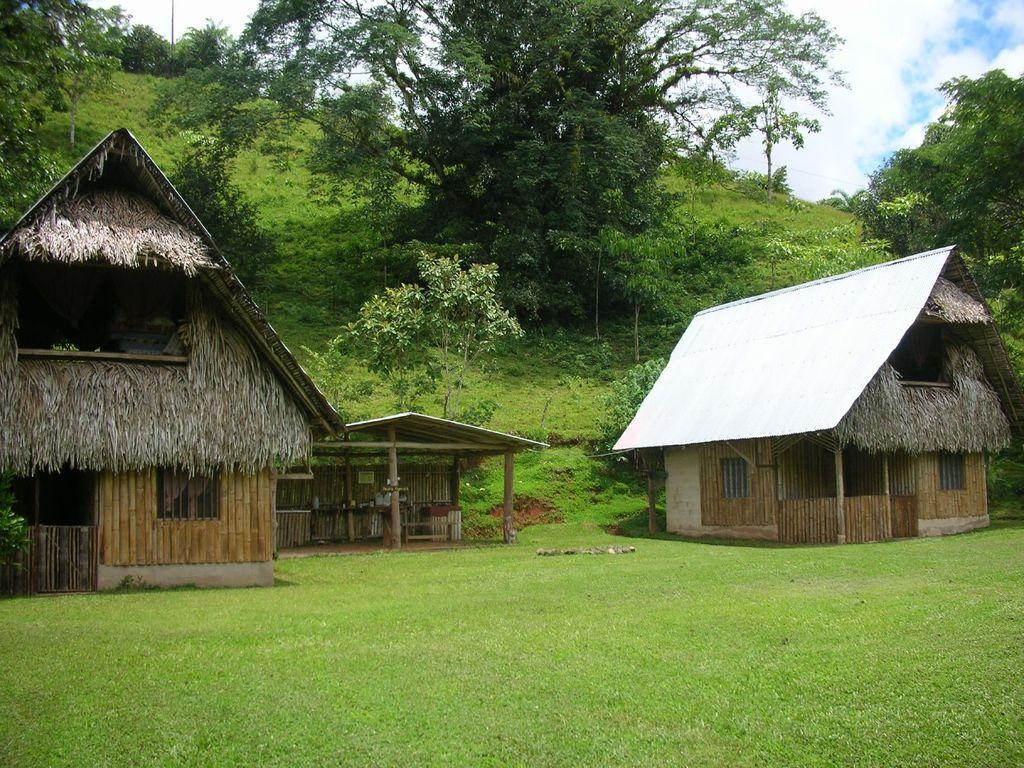How many wooden houses are present in the image? There are three wooden houses in the image. What type of vegetation can be seen in the background of the image? There are trees in the background of the image. What force is causing the doll to levitate in the image? There is no doll present in the image, and therefore no levitation or force can be observed. How many toes can be seen on the wooden houses in the image? Wooden houses do not have toes, as they are inanimate objects. 